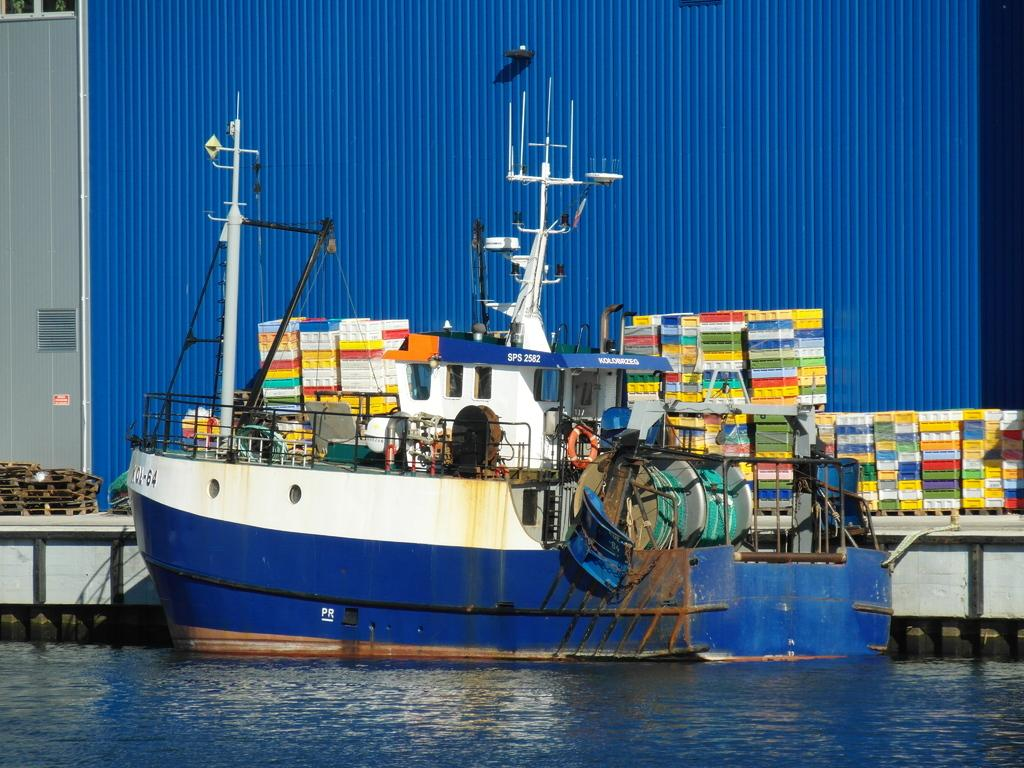What is the main subject of the image? The main subject of the image is a boat. Where is the boat located? The boat is on the water. What safety device is present on the boat? There is a lifebuoy on the boat. What can be seen behind the boat? There are plastic objects and a blue iron sheet behind the boat, along with other objects. What type of food is being prepared on the boat in the image? There is no indication of food preparation in the image; the focus is on the boat, its location, and the safety device present. 